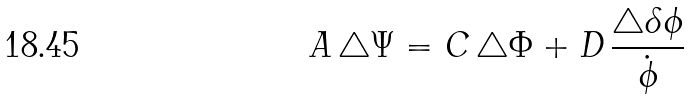<formula> <loc_0><loc_0><loc_500><loc_500>A \, \triangle \Psi = C \, \triangle \Phi + D \, { \frac { \triangle \delta \phi } { \dot { \phi } } }</formula> 